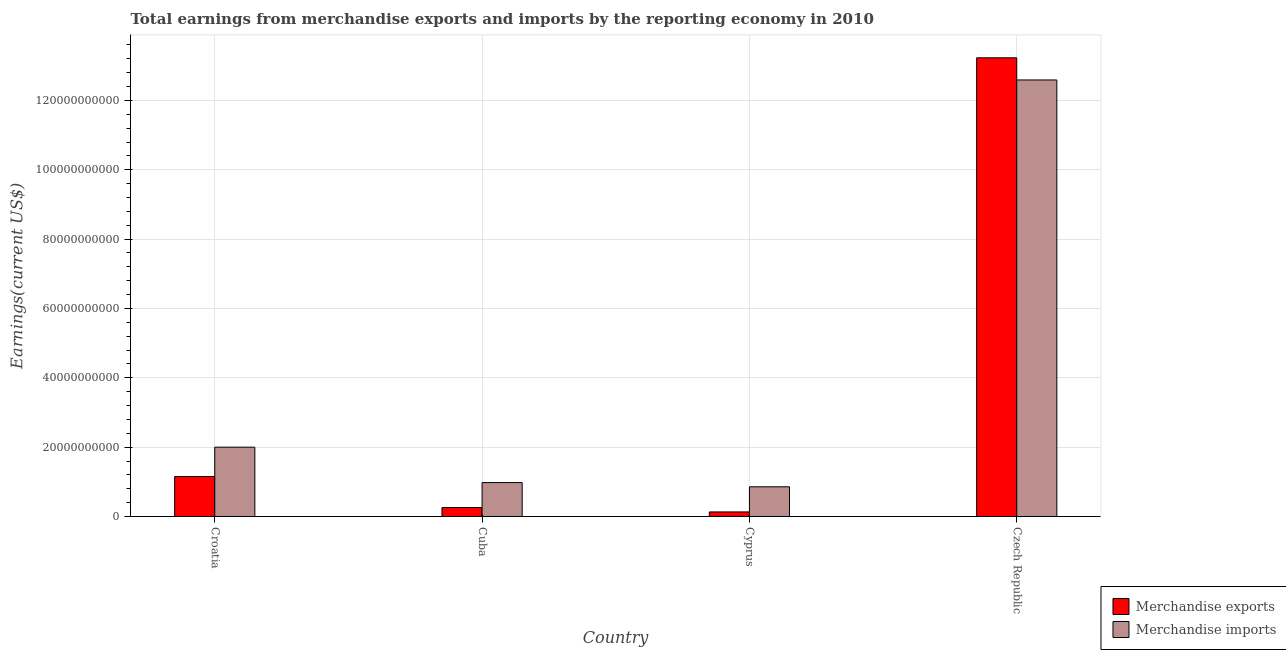How many different coloured bars are there?
Make the answer very short. 2. How many bars are there on the 2nd tick from the right?
Ensure brevity in your answer.  2. What is the label of the 1st group of bars from the left?
Provide a short and direct response. Croatia. In how many cases, is the number of bars for a given country not equal to the number of legend labels?
Ensure brevity in your answer.  0. What is the earnings from merchandise imports in Czech Republic?
Provide a succinct answer. 1.26e+11. Across all countries, what is the maximum earnings from merchandise imports?
Provide a succinct answer. 1.26e+11. Across all countries, what is the minimum earnings from merchandise exports?
Offer a terse response. 1.32e+09. In which country was the earnings from merchandise exports maximum?
Offer a terse response. Czech Republic. In which country was the earnings from merchandise imports minimum?
Keep it short and to the point. Cyprus. What is the total earnings from merchandise imports in the graph?
Offer a very short reply. 1.64e+11. What is the difference between the earnings from merchandise exports in Cuba and that in Cyprus?
Provide a short and direct response. 1.27e+09. What is the difference between the earnings from merchandise exports in Cyprus and the earnings from merchandise imports in Czech Republic?
Your answer should be very brief. -1.25e+11. What is the average earnings from merchandise exports per country?
Your answer should be very brief. 3.69e+1. What is the difference between the earnings from merchandise exports and earnings from merchandise imports in Czech Republic?
Ensure brevity in your answer.  6.39e+09. What is the ratio of the earnings from merchandise imports in Croatia to that in Cyprus?
Offer a very short reply. 2.33. Is the earnings from merchandise imports in Croatia less than that in Cyprus?
Offer a terse response. No. Is the difference between the earnings from merchandise exports in Croatia and Czech Republic greater than the difference between the earnings from merchandise imports in Croatia and Czech Republic?
Provide a short and direct response. No. What is the difference between the highest and the second highest earnings from merchandise exports?
Your answer should be compact. 1.21e+11. What is the difference between the highest and the lowest earnings from merchandise exports?
Provide a short and direct response. 1.31e+11. Is the sum of the earnings from merchandise imports in Cuba and Czech Republic greater than the maximum earnings from merchandise exports across all countries?
Your response must be concise. Yes. What does the 2nd bar from the left in Cuba represents?
Your answer should be compact. Merchandise imports. How many bars are there?
Your response must be concise. 8. How many countries are there in the graph?
Keep it short and to the point. 4. What is the difference between two consecutive major ticks on the Y-axis?
Your answer should be compact. 2.00e+1. Does the graph contain any zero values?
Make the answer very short. No. Does the graph contain grids?
Your response must be concise. Yes. How are the legend labels stacked?
Provide a short and direct response. Vertical. What is the title of the graph?
Offer a very short reply. Total earnings from merchandise exports and imports by the reporting economy in 2010. What is the label or title of the X-axis?
Make the answer very short. Country. What is the label or title of the Y-axis?
Keep it short and to the point. Earnings(current US$). What is the Earnings(current US$) of Merchandise exports in Croatia?
Keep it short and to the point. 1.15e+1. What is the Earnings(current US$) in Merchandise imports in Croatia?
Offer a terse response. 2.00e+1. What is the Earnings(current US$) in Merchandise exports in Cuba?
Keep it short and to the point. 2.58e+09. What is the Earnings(current US$) of Merchandise imports in Cuba?
Your response must be concise. 9.78e+09. What is the Earnings(current US$) in Merchandise exports in Cyprus?
Ensure brevity in your answer.  1.32e+09. What is the Earnings(current US$) in Merchandise imports in Cyprus?
Your response must be concise. 8.56e+09. What is the Earnings(current US$) in Merchandise exports in Czech Republic?
Offer a very short reply. 1.32e+11. What is the Earnings(current US$) of Merchandise imports in Czech Republic?
Offer a very short reply. 1.26e+11. Across all countries, what is the maximum Earnings(current US$) in Merchandise exports?
Provide a succinct answer. 1.32e+11. Across all countries, what is the maximum Earnings(current US$) of Merchandise imports?
Provide a succinct answer. 1.26e+11. Across all countries, what is the minimum Earnings(current US$) in Merchandise exports?
Offer a very short reply. 1.32e+09. Across all countries, what is the minimum Earnings(current US$) of Merchandise imports?
Make the answer very short. 8.56e+09. What is the total Earnings(current US$) in Merchandise exports in the graph?
Your answer should be very brief. 1.48e+11. What is the total Earnings(current US$) in Merchandise imports in the graph?
Offer a very short reply. 1.64e+11. What is the difference between the Earnings(current US$) of Merchandise exports in Croatia and that in Cuba?
Your answer should be very brief. 8.94e+09. What is the difference between the Earnings(current US$) of Merchandise imports in Croatia and that in Cuba?
Your response must be concise. 1.02e+1. What is the difference between the Earnings(current US$) in Merchandise exports in Croatia and that in Cyprus?
Your answer should be compact. 1.02e+1. What is the difference between the Earnings(current US$) of Merchandise imports in Croatia and that in Cyprus?
Your response must be concise. 1.14e+1. What is the difference between the Earnings(current US$) in Merchandise exports in Croatia and that in Czech Republic?
Offer a very short reply. -1.21e+11. What is the difference between the Earnings(current US$) of Merchandise imports in Croatia and that in Czech Republic?
Give a very brief answer. -1.06e+11. What is the difference between the Earnings(current US$) of Merchandise exports in Cuba and that in Cyprus?
Provide a succinct answer. 1.27e+09. What is the difference between the Earnings(current US$) in Merchandise imports in Cuba and that in Cyprus?
Your answer should be compact. 1.22e+09. What is the difference between the Earnings(current US$) in Merchandise exports in Cuba and that in Czech Republic?
Your response must be concise. -1.30e+11. What is the difference between the Earnings(current US$) in Merchandise imports in Cuba and that in Czech Republic?
Your answer should be compact. -1.16e+11. What is the difference between the Earnings(current US$) in Merchandise exports in Cyprus and that in Czech Republic?
Your answer should be very brief. -1.31e+11. What is the difference between the Earnings(current US$) in Merchandise imports in Cyprus and that in Czech Republic?
Provide a succinct answer. -1.17e+11. What is the difference between the Earnings(current US$) in Merchandise exports in Croatia and the Earnings(current US$) in Merchandise imports in Cuba?
Provide a short and direct response. 1.74e+09. What is the difference between the Earnings(current US$) of Merchandise exports in Croatia and the Earnings(current US$) of Merchandise imports in Cyprus?
Your answer should be compact. 2.96e+09. What is the difference between the Earnings(current US$) of Merchandise exports in Croatia and the Earnings(current US$) of Merchandise imports in Czech Republic?
Give a very brief answer. -1.14e+11. What is the difference between the Earnings(current US$) of Merchandise exports in Cuba and the Earnings(current US$) of Merchandise imports in Cyprus?
Keep it short and to the point. -5.98e+09. What is the difference between the Earnings(current US$) of Merchandise exports in Cuba and the Earnings(current US$) of Merchandise imports in Czech Republic?
Offer a very short reply. -1.23e+11. What is the difference between the Earnings(current US$) of Merchandise exports in Cyprus and the Earnings(current US$) of Merchandise imports in Czech Republic?
Provide a short and direct response. -1.25e+11. What is the average Earnings(current US$) of Merchandise exports per country?
Provide a short and direct response. 3.69e+1. What is the average Earnings(current US$) of Merchandise imports per country?
Provide a succinct answer. 4.11e+1. What is the difference between the Earnings(current US$) of Merchandise exports and Earnings(current US$) of Merchandise imports in Croatia?
Offer a very short reply. -8.47e+09. What is the difference between the Earnings(current US$) of Merchandise exports and Earnings(current US$) of Merchandise imports in Cuba?
Keep it short and to the point. -7.19e+09. What is the difference between the Earnings(current US$) in Merchandise exports and Earnings(current US$) in Merchandise imports in Cyprus?
Offer a very short reply. -7.25e+09. What is the difference between the Earnings(current US$) of Merchandise exports and Earnings(current US$) of Merchandise imports in Czech Republic?
Your answer should be very brief. 6.39e+09. What is the ratio of the Earnings(current US$) in Merchandise exports in Croatia to that in Cuba?
Give a very brief answer. 4.46. What is the ratio of the Earnings(current US$) of Merchandise imports in Croatia to that in Cuba?
Provide a succinct answer. 2.04. What is the ratio of the Earnings(current US$) of Merchandise exports in Croatia to that in Cyprus?
Offer a very short reply. 8.76. What is the ratio of the Earnings(current US$) in Merchandise imports in Croatia to that in Cyprus?
Offer a very short reply. 2.33. What is the ratio of the Earnings(current US$) of Merchandise exports in Croatia to that in Czech Republic?
Offer a terse response. 0.09. What is the ratio of the Earnings(current US$) of Merchandise imports in Croatia to that in Czech Republic?
Ensure brevity in your answer.  0.16. What is the ratio of the Earnings(current US$) of Merchandise exports in Cuba to that in Cyprus?
Ensure brevity in your answer.  1.96. What is the ratio of the Earnings(current US$) of Merchandise imports in Cuba to that in Cyprus?
Your answer should be very brief. 1.14. What is the ratio of the Earnings(current US$) in Merchandise exports in Cuba to that in Czech Republic?
Give a very brief answer. 0.02. What is the ratio of the Earnings(current US$) of Merchandise imports in Cuba to that in Czech Republic?
Provide a short and direct response. 0.08. What is the ratio of the Earnings(current US$) of Merchandise exports in Cyprus to that in Czech Republic?
Your answer should be very brief. 0.01. What is the ratio of the Earnings(current US$) in Merchandise imports in Cyprus to that in Czech Republic?
Give a very brief answer. 0.07. What is the difference between the highest and the second highest Earnings(current US$) in Merchandise exports?
Provide a short and direct response. 1.21e+11. What is the difference between the highest and the second highest Earnings(current US$) of Merchandise imports?
Your response must be concise. 1.06e+11. What is the difference between the highest and the lowest Earnings(current US$) of Merchandise exports?
Make the answer very short. 1.31e+11. What is the difference between the highest and the lowest Earnings(current US$) of Merchandise imports?
Keep it short and to the point. 1.17e+11. 